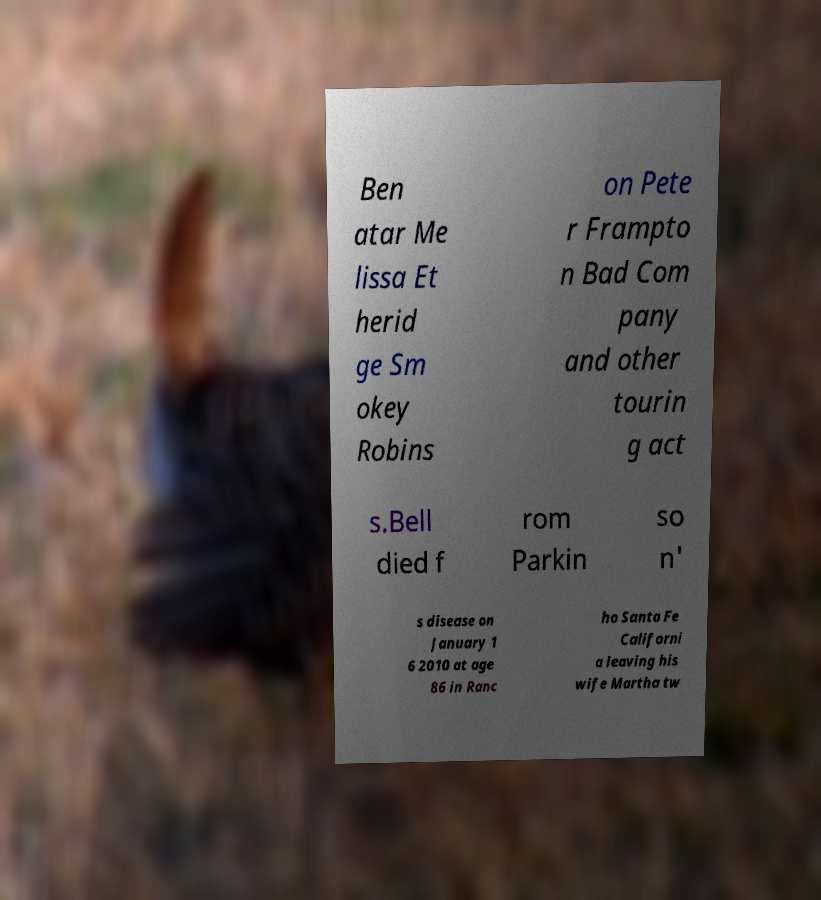There's text embedded in this image that I need extracted. Can you transcribe it verbatim? Ben atar Me lissa Et herid ge Sm okey Robins on Pete r Frampto n Bad Com pany and other tourin g act s.Bell died f rom Parkin so n' s disease on January 1 6 2010 at age 86 in Ranc ho Santa Fe Californi a leaving his wife Martha tw 